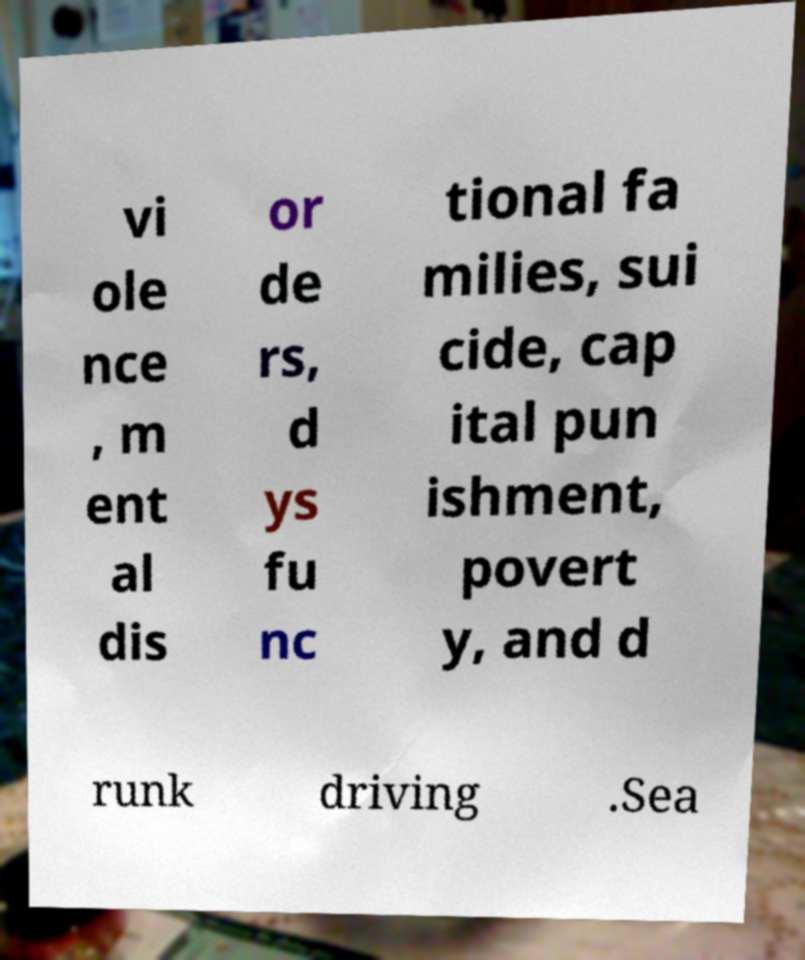Can you read and provide the text displayed in the image?This photo seems to have some interesting text. Can you extract and type it out for me? vi ole nce , m ent al dis or de rs, d ys fu nc tional fa milies, sui cide, cap ital pun ishment, povert y, and d runk driving .Sea 